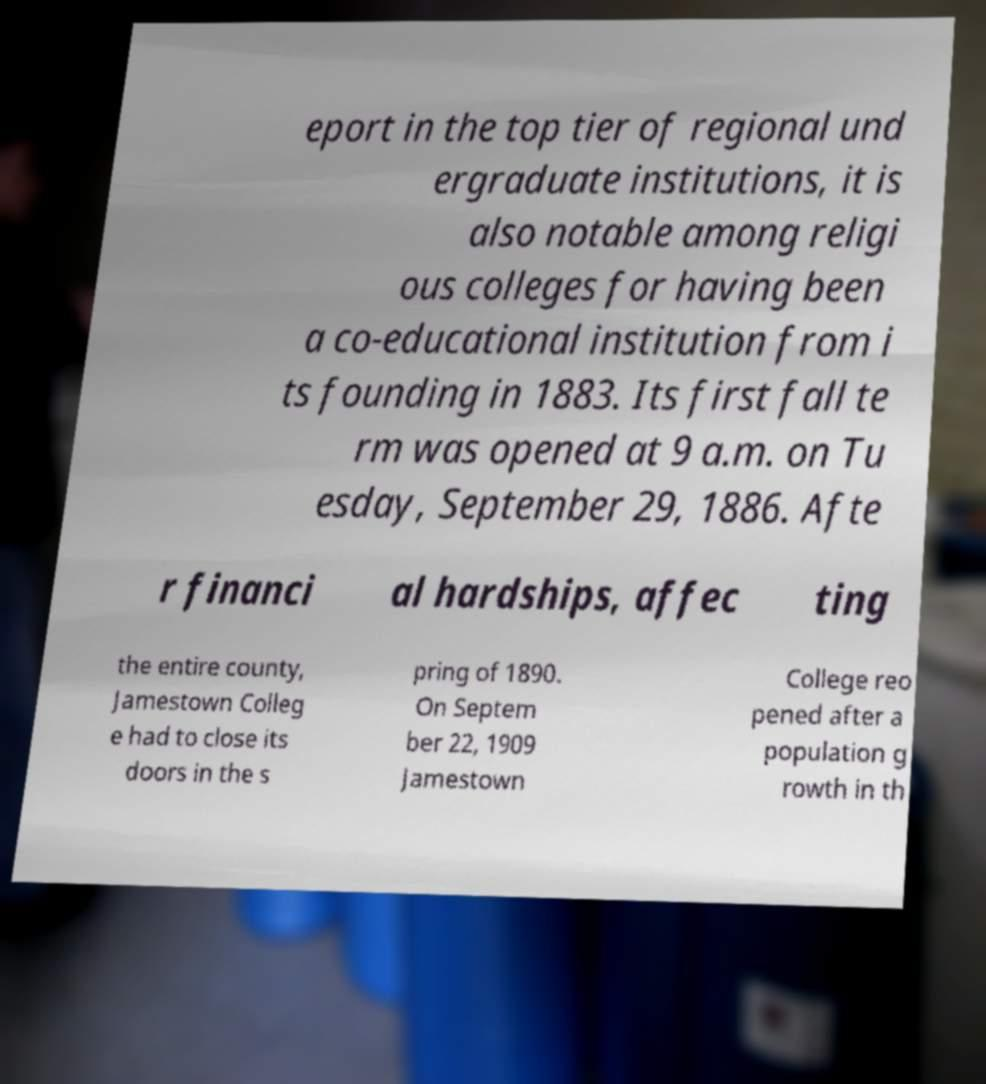Can you accurately transcribe the text from the provided image for me? eport in the top tier of regional und ergraduate institutions, it is also notable among religi ous colleges for having been a co-educational institution from i ts founding in 1883. Its first fall te rm was opened at 9 a.m. on Tu esday, September 29, 1886. Afte r financi al hardships, affec ting the entire county, Jamestown Colleg e had to close its doors in the s pring of 1890. On Septem ber 22, 1909 Jamestown College reo pened after a population g rowth in th 